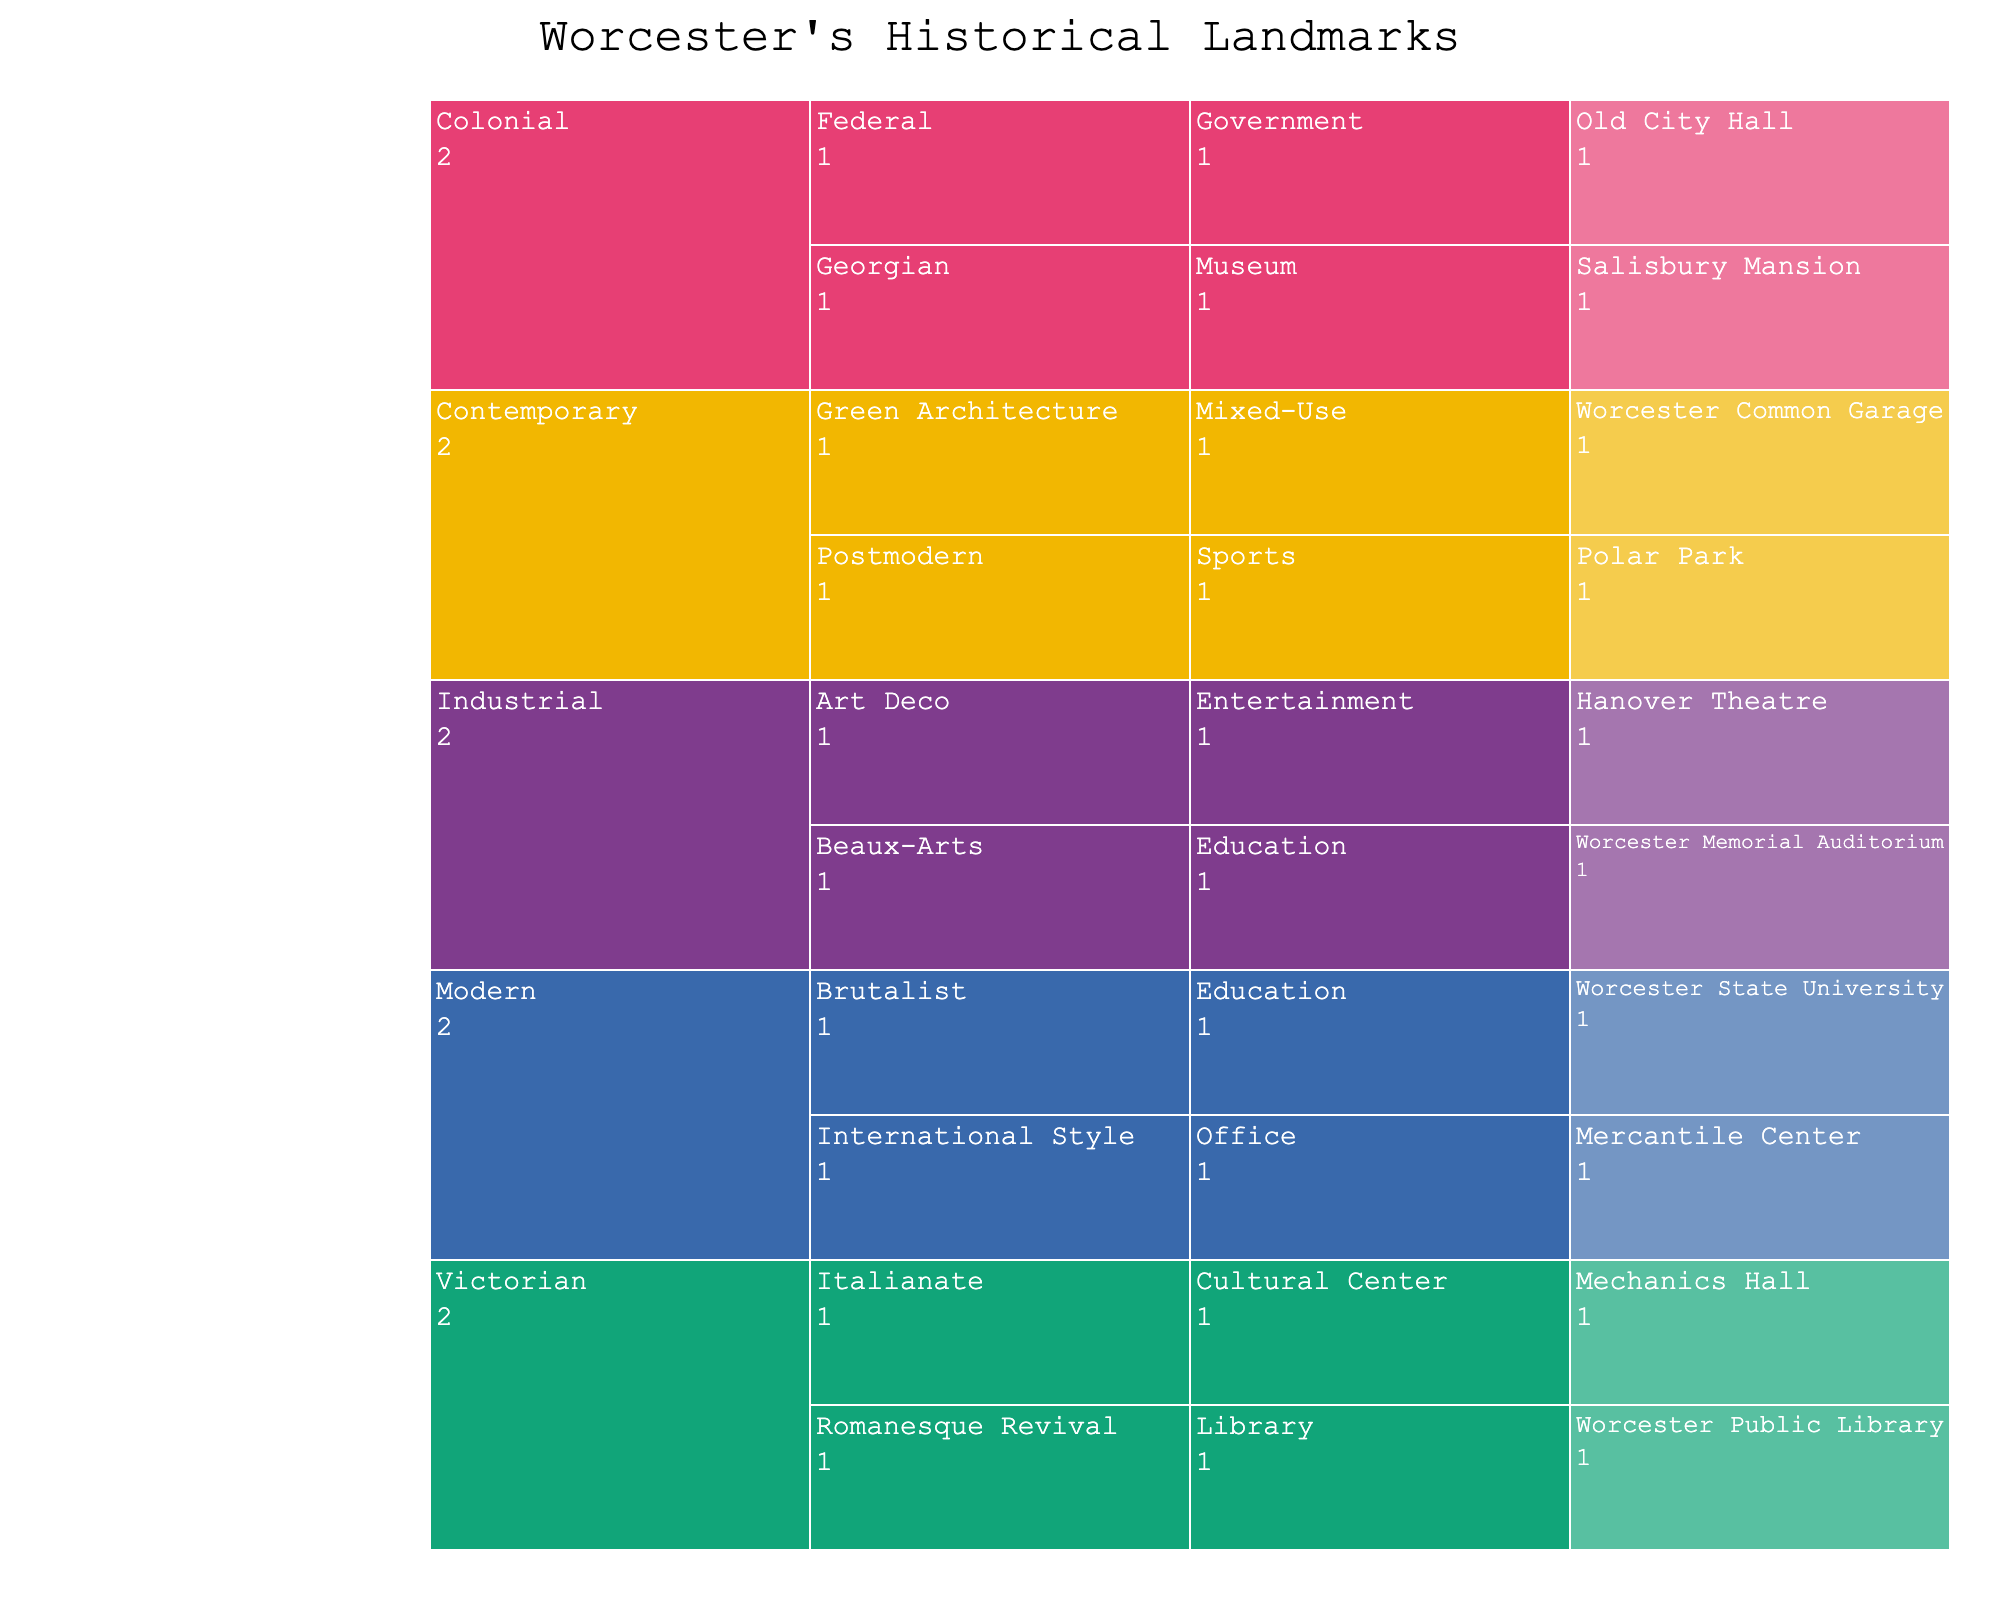What is the title of the figure? The title of the figure is usually displayed prominently at the top of the chart. Here, it reads "Worcester's Historical Landmarks" based on the defined title in the provided code.
Answer: Worcester's Historical Landmarks How many eras are represented in the icicle chart? The icicle chart has different colored sections for each "Era" level in the hierarchy. By counting the distinct sections at the top level, we see there are four eras represented: Colonial, Victorian, Industrial, and Modern, and Contemporary.
Answer: 5 Which era has the highest number of landmarks? By observing the levels under each "Era" section, we can count the number of landmarks. The Victorian era has Mechanics Hall and Worcester Public Library, which amounts to two, Industrial has two, Colonial has two, Modern has two, and Contemporary has two. Although it appears that multiple eras have the same number of landmarks, they all have two each.
Answer: All eras have 2 landmarks each Which architectural style appears under the 'Industrial' era? The icicle chart breaks down each era into different architectural styles. Under the 'Industrial' era, there are two styles: Beaux-Arts and Art Deco.
Answer: Beaux-Arts and Art Deco What current usage categories exist in the Modern era? Under the 'Modern' era, the chart further categorizes landmarks into their current usage. The two categories visible in the figure are Office (Mercantile Center) and Education (Worcester State University).
Answer: Office and Education How many landmarks are categorized under the 'Cultural Center' usage? Navigating through the 'Current Usage' level of the figure, we see that 'Cultural Center' has one landmark listed under it, which is Mechanics Hall.
Answer: 1 Which landmark is under the 'Brutalist' architectural style? Observing the 'Architectural Style' layer, the 'Brutalist' style is classified under the 'Modern' era, with the landmark being Worcester State University.
Answer: Worcester State University Is there more than one landmark used as a sports facility? By examining the 'Current Usage' level, only one landmark listed as a sports facility, which is Polar Park under the 'Postmodern' style of the 'Contemporary' era.
Answer: No, only one Compare the number of landmarks in the Victorian and Colonial eras? Counting the landmarks listed under each era in the chart, we find both the Victorian and Colonial eras have two landmarks each.
Answer: They have the same number What is the current usage of Hanover Theatre? Following the hierarchical levels down to the landmark, Hanover Theatre falls under the 'Industrial' era, 'Art Deco' style, and it is used for Entertainment.
Answer: Entertainment 